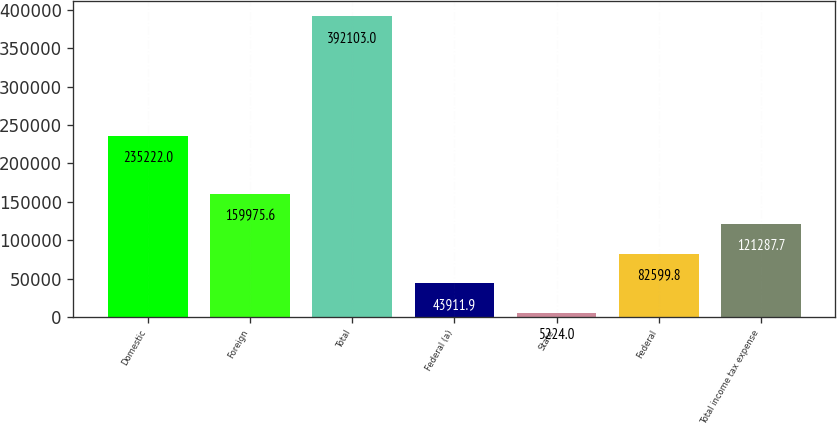<chart> <loc_0><loc_0><loc_500><loc_500><bar_chart><fcel>Domestic<fcel>Foreign<fcel>Total<fcel>Federal (a)<fcel>State<fcel>Federal<fcel>Total income tax expense<nl><fcel>235222<fcel>159976<fcel>392103<fcel>43911.9<fcel>5224<fcel>82599.8<fcel>121288<nl></chart> 